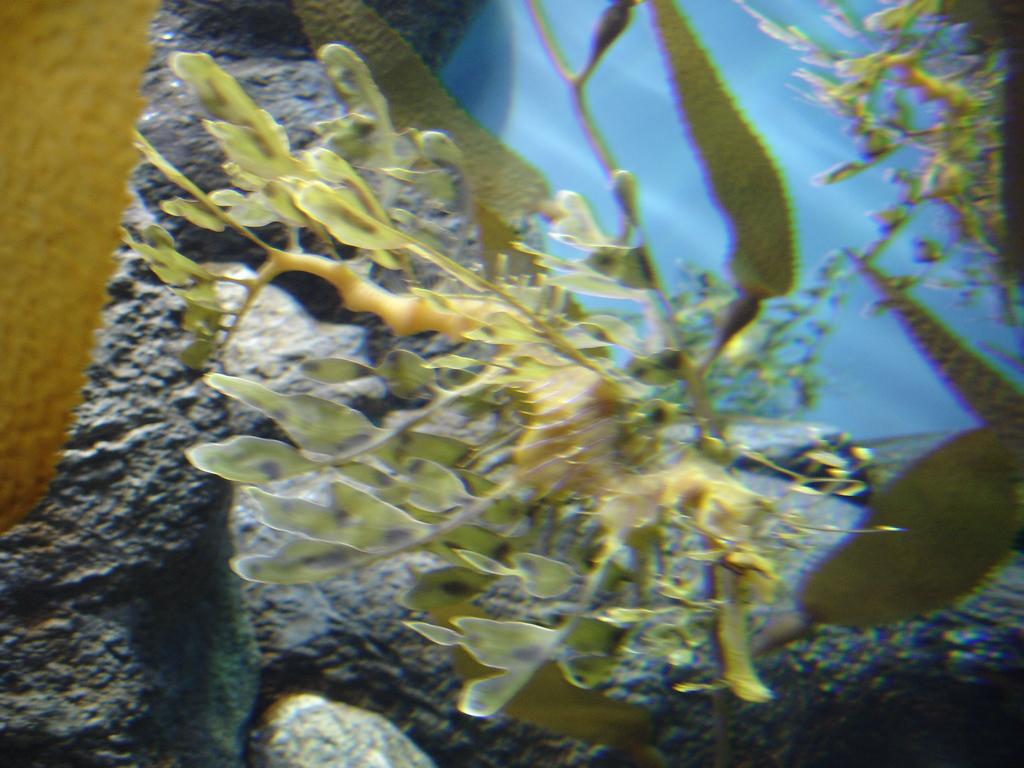What type of living organism is present in the image? There is a plant in the image. What other objects can be seen in the image? There are rocks in the image. What is visible at the side of the image? There appears to be water at the side of the image. What type of lettuce is being used as a floor covering in the image? There is no lettuce present in the image, nor is there any indication of a floor or floor covering. 